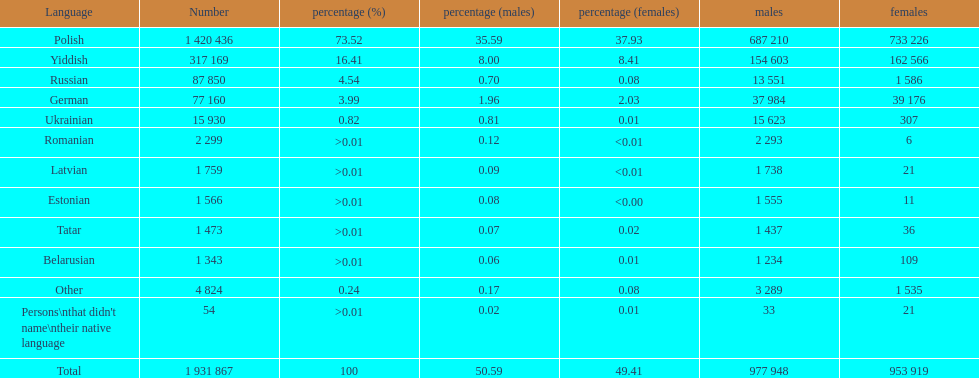The least amount of females Romanian. 